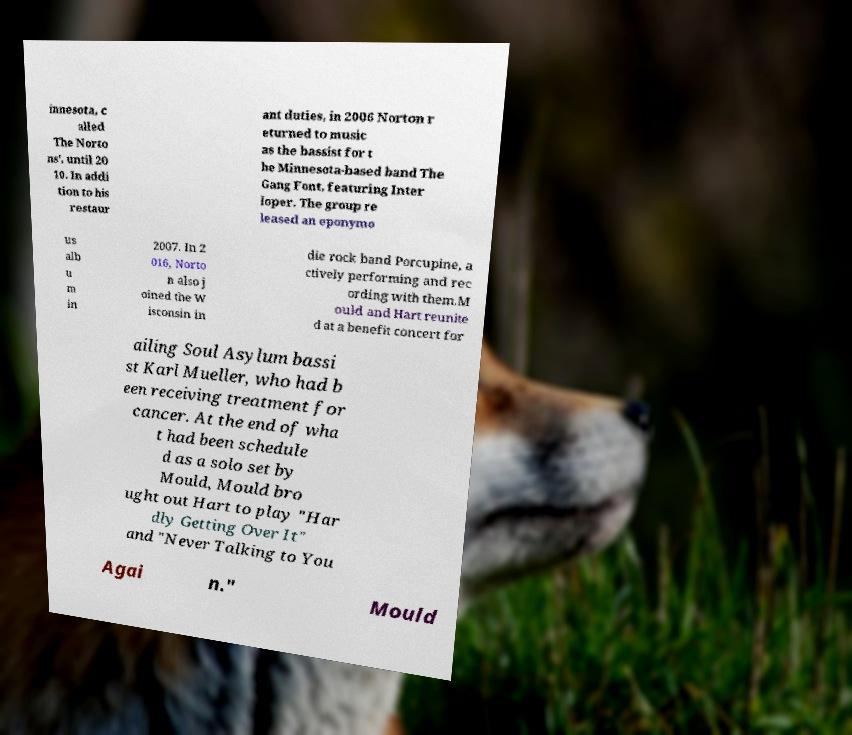Can you read and provide the text displayed in the image?This photo seems to have some interesting text. Can you extract and type it out for me? innesota, c alled The Norto ns', until 20 10. In addi tion to his restaur ant duties, in 2006 Norton r eturned to music as the bassist for t he Minnesota-based band The Gang Font, featuring Inter loper. The group re leased an eponymo us alb u m in 2007. In 2 016, Norto n also j oined the W isconsin in die rock band Porcupine, a ctively performing and rec ording with them.M ould and Hart reunite d at a benefit concert for ailing Soul Asylum bassi st Karl Mueller, who had b een receiving treatment for cancer. At the end of wha t had been schedule d as a solo set by Mould, Mould bro ught out Hart to play "Har dly Getting Over It" and "Never Talking to You Agai n." Mould 